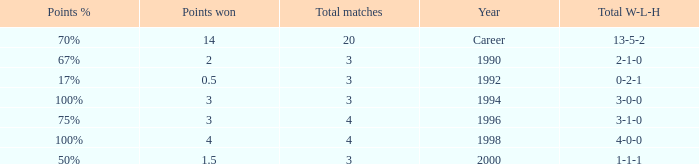Can you tell me the lowest Points won that has the Total matches of 4, and the Total W-L-H of 4-0-0? 4.0. 